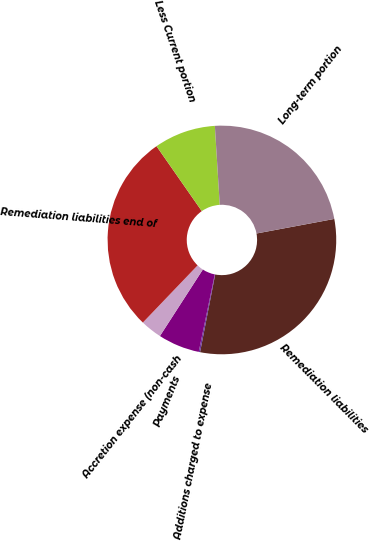Convert chart to OTSL. <chart><loc_0><loc_0><loc_500><loc_500><pie_chart><fcel>Remediation liabilities<fcel>Additions charged to expense<fcel>Payments<fcel>Accretion expense (non-cash<fcel>Remediation liabilities end of<fcel>Less Current portion<fcel>Long-term portion<nl><fcel>31.01%<fcel>0.19%<fcel>5.87%<fcel>3.03%<fcel>28.16%<fcel>8.71%<fcel>23.04%<nl></chart> 